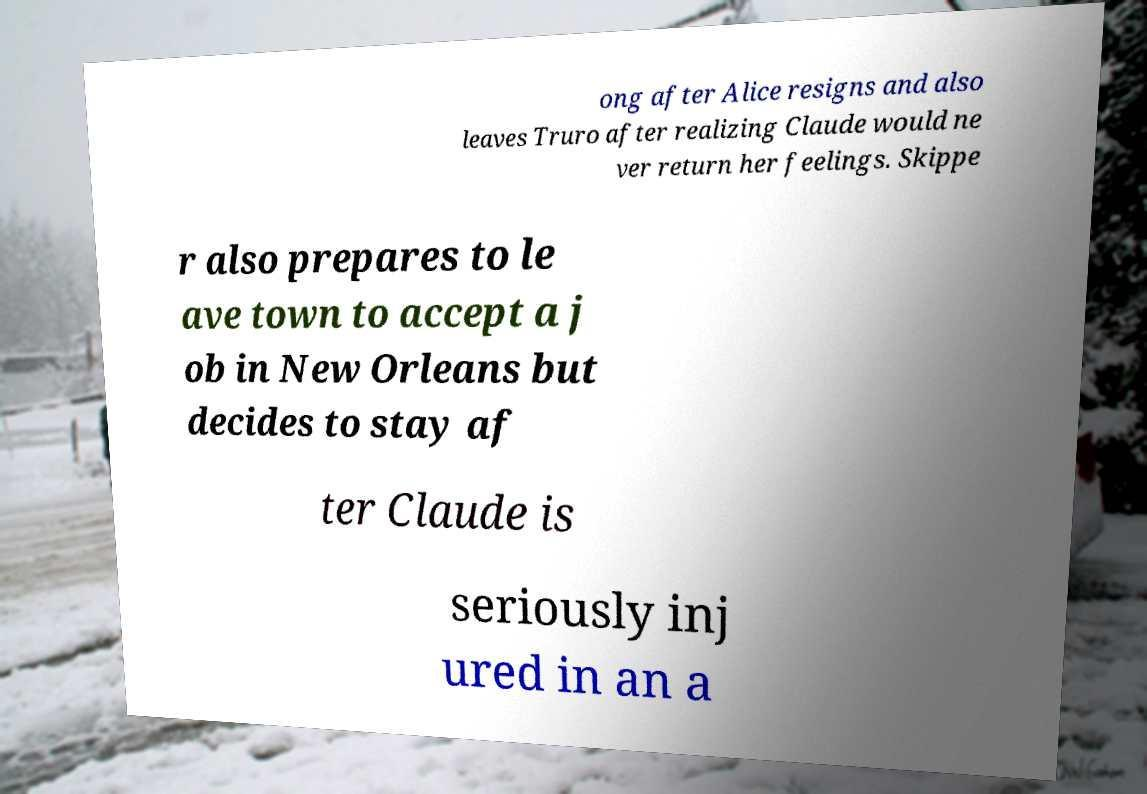Please identify and transcribe the text found in this image. ong after Alice resigns and also leaves Truro after realizing Claude would ne ver return her feelings. Skippe r also prepares to le ave town to accept a j ob in New Orleans but decides to stay af ter Claude is seriously inj ured in an a 